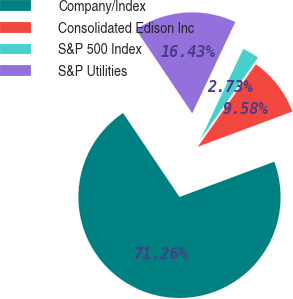Convert chart. <chart><loc_0><loc_0><loc_500><loc_500><pie_chart><fcel>Company/Index<fcel>Consolidated Edison Inc<fcel>S&P 500 Index<fcel>S&P Utilities<nl><fcel>71.25%<fcel>9.58%<fcel>2.73%<fcel>16.43%<nl></chart> 